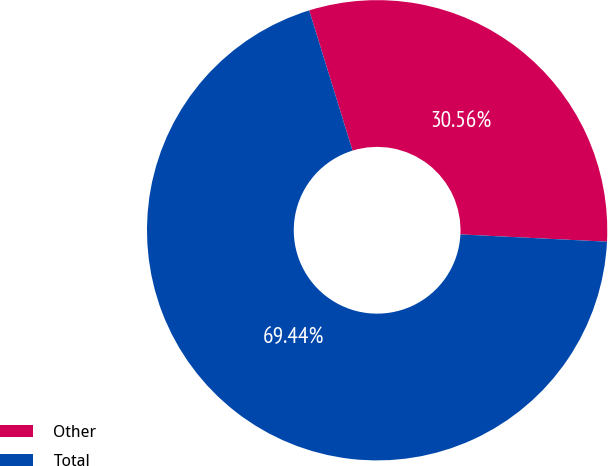Convert chart to OTSL. <chart><loc_0><loc_0><loc_500><loc_500><pie_chart><fcel>Other<fcel>Total<nl><fcel>30.56%<fcel>69.44%<nl></chart> 